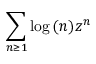<formula> <loc_0><loc_0><loc_500><loc_500>\sum _ { n \geq 1 } \log { ( n ) } z ^ { n }</formula> 